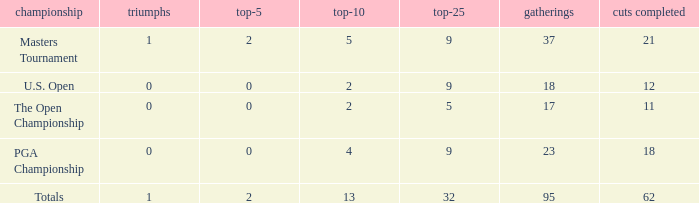What is the lowest top 5 winners with less than 0? None. 